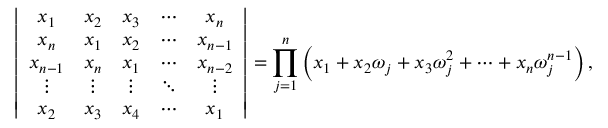<formula> <loc_0><loc_0><loc_500><loc_500>\left | { \begin{array} { c c c c c } { x _ { 1 } } & { x _ { 2 } } & { x _ { 3 } } & { \cdots } & { x _ { n } } \\ { x _ { n } } & { x _ { 1 } } & { x _ { 2 } } & { \cdots } & { x _ { n - 1 } } \\ { x _ { n - 1 } } & { x _ { n } } & { x _ { 1 } } & { \cdots } & { x _ { n - 2 } } \\ { \vdots } & { \vdots } & { \vdots } & { \ddots } & { \vdots } \\ { x _ { 2 } } & { x _ { 3 } } & { x _ { 4 } } & { \cdots } & { x _ { 1 } } \end{array} } \right | = \prod _ { j = 1 } ^ { n } \left ( x _ { 1 } + x _ { 2 } \omega _ { j } + x _ { 3 } \omega _ { j } ^ { 2 } + \cdots + x _ { n } \omega _ { j } ^ { n - 1 } \right ) ,</formula> 